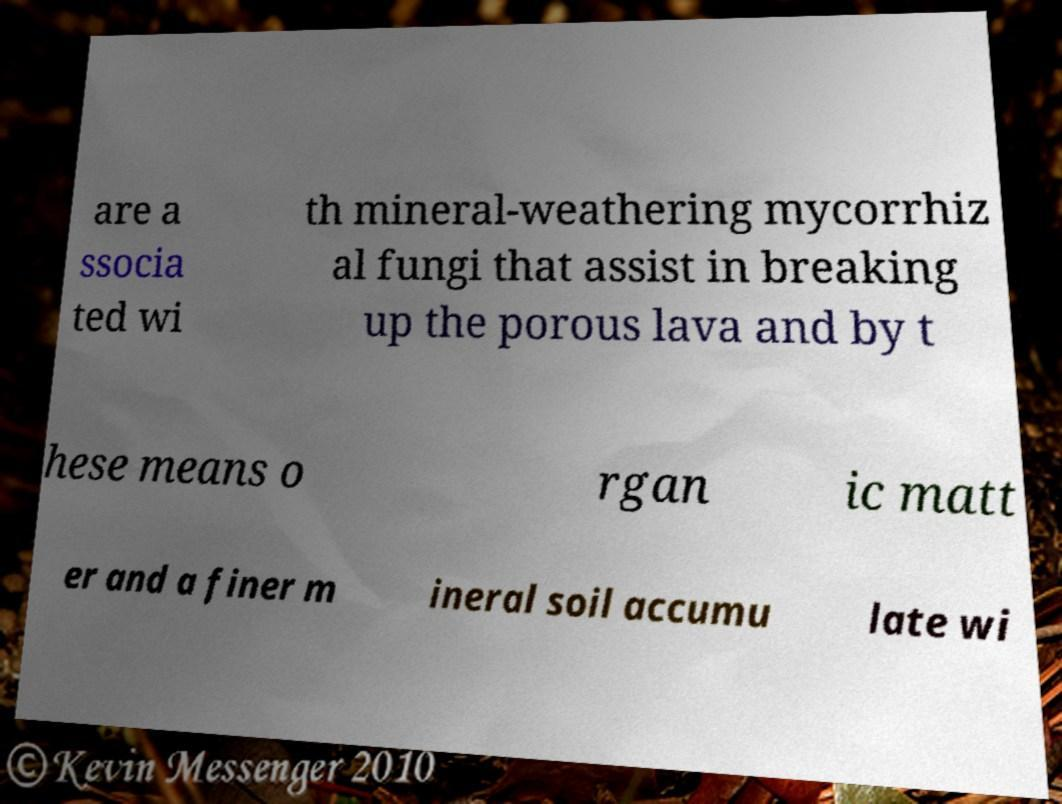Please read and relay the text visible in this image. What does it say? are a ssocia ted wi th mineral-weathering mycorrhiz al fungi that assist in breaking up the porous lava and by t hese means o rgan ic matt er and a finer m ineral soil accumu late wi 